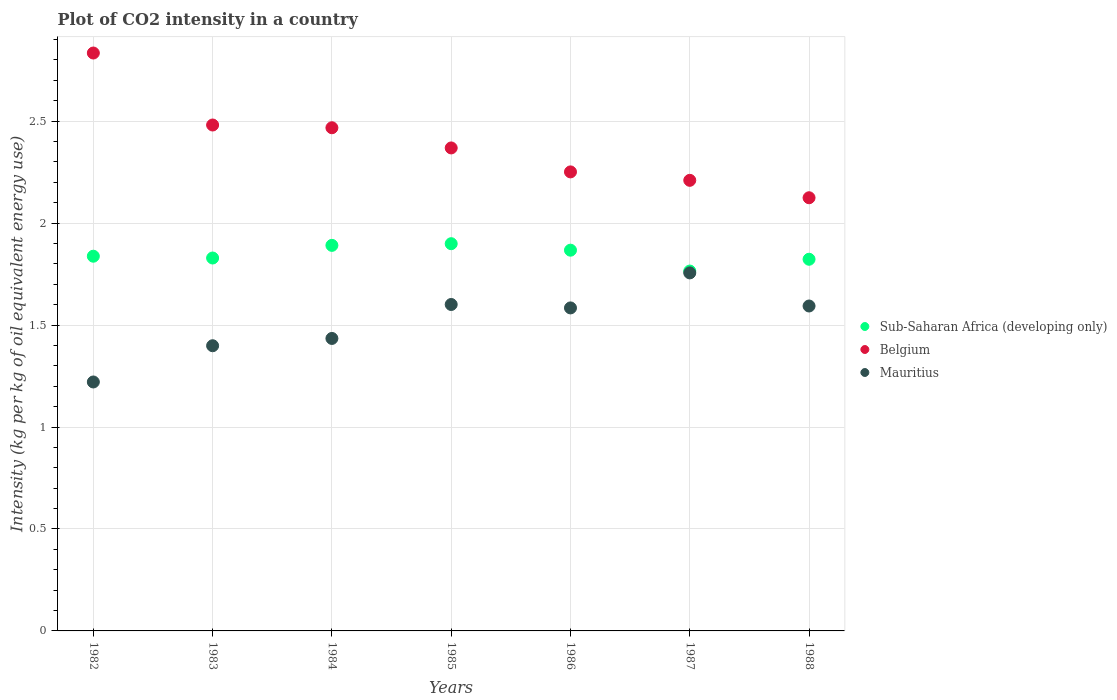How many different coloured dotlines are there?
Keep it short and to the point. 3. Is the number of dotlines equal to the number of legend labels?
Ensure brevity in your answer.  Yes. What is the CO2 intensity in in Sub-Saharan Africa (developing only) in 1984?
Offer a very short reply. 1.89. Across all years, what is the maximum CO2 intensity in in Belgium?
Provide a short and direct response. 2.83. Across all years, what is the minimum CO2 intensity in in Belgium?
Offer a very short reply. 2.12. What is the total CO2 intensity in in Belgium in the graph?
Provide a succinct answer. 16.74. What is the difference between the CO2 intensity in in Belgium in 1982 and that in 1984?
Your answer should be compact. 0.37. What is the difference between the CO2 intensity in in Mauritius in 1988 and the CO2 intensity in in Belgium in 1986?
Offer a very short reply. -0.66. What is the average CO2 intensity in in Sub-Saharan Africa (developing only) per year?
Keep it short and to the point. 1.84. In the year 1983, what is the difference between the CO2 intensity in in Belgium and CO2 intensity in in Sub-Saharan Africa (developing only)?
Your answer should be very brief. 0.65. In how many years, is the CO2 intensity in in Mauritius greater than 1 kg?
Provide a short and direct response. 7. What is the ratio of the CO2 intensity in in Belgium in 1982 to that in 1983?
Give a very brief answer. 1.14. Is the CO2 intensity in in Mauritius in 1984 less than that in 1987?
Offer a very short reply. Yes. What is the difference between the highest and the second highest CO2 intensity in in Belgium?
Offer a terse response. 0.35. What is the difference between the highest and the lowest CO2 intensity in in Belgium?
Make the answer very short. 0.71. In how many years, is the CO2 intensity in in Belgium greater than the average CO2 intensity in in Belgium taken over all years?
Offer a very short reply. 3. Is the sum of the CO2 intensity in in Mauritius in 1986 and 1988 greater than the maximum CO2 intensity in in Sub-Saharan Africa (developing only) across all years?
Offer a terse response. Yes. Is it the case that in every year, the sum of the CO2 intensity in in Belgium and CO2 intensity in in Sub-Saharan Africa (developing only)  is greater than the CO2 intensity in in Mauritius?
Your answer should be very brief. Yes. Is the CO2 intensity in in Mauritius strictly greater than the CO2 intensity in in Belgium over the years?
Your answer should be compact. No. What is the difference between two consecutive major ticks on the Y-axis?
Offer a very short reply. 0.5. Are the values on the major ticks of Y-axis written in scientific E-notation?
Offer a very short reply. No. How are the legend labels stacked?
Give a very brief answer. Vertical. What is the title of the graph?
Offer a very short reply. Plot of CO2 intensity in a country. What is the label or title of the X-axis?
Ensure brevity in your answer.  Years. What is the label or title of the Y-axis?
Offer a very short reply. Intensity (kg per kg of oil equivalent energy use). What is the Intensity (kg per kg of oil equivalent energy use) of Sub-Saharan Africa (developing only) in 1982?
Your answer should be compact. 1.84. What is the Intensity (kg per kg of oil equivalent energy use) in Belgium in 1982?
Make the answer very short. 2.83. What is the Intensity (kg per kg of oil equivalent energy use) in Mauritius in 1982?
Keep it short and to the point. 1.22. What is the Intensity (kg per kg of oil equivalent energy use) in Sub-Saharan Africa (developing only) in 1983?
Make the answer very short. 1.83. What is the Intensity (kg per kg of oil equivalent energy use) of Belgium in 1983?
Keep it short and to the point. 2.48. What is the Intensity (kg per kg of oil equivalent energy use) of Mauritius in 1983?
Provide a short and direct response. 1.4. What is the Intensity (kg per kg of oil equivalent energy use) in Sub-Saharan Africa (developing only) in 1984?
Make the answer very short. 1.89. What is the Intensity (kg per kg of oil equivalent energy use) of Belgium in 1984?
Offer a terse response. 2.47. What is the Intensity (kg per kg of oil equivalent energy use) in Mauritius in 1984?
Ensure brevity in your answer.  1.43. What is the Intensity (kg per kg of oil equivalent energy use) of Sub-Saharan Africa (developing only) in 1985?
Make the answer very short. 1.9. What is the Intensity (kg per kg of oil equivalent energy use) in Belgium in 1985?
Offer a very short reply. 2.37. What is the Intensity (kg per kg of oil equivalent energy use) in Mauritius in 1985?
Make the answer very short. 1.6. What is the Intensity (kg per kg of oil equivalent energy use) in Sub-Saharan Africa (developing only) in 1986?
Keep it short and to the point. 1.87. What is the Intensity (kg per kg of oil equivalent energy use) of Belgium in 1986?
Your response must be concise. 2.25. What is the Intensity (kg per kg of oil equivalent energy use) of Mauritius in 1986?
Your response must be concise. 1.58. What is the Intensity (kg per kg of oil equivalent energy use) in Sub-Saharan Africa (developing only) in 1987?
Keep it short and to the point. 1.76. What is the Intensity (kg per kg of oil equivalent energy use) in Belgium in 1987?
Make the answer very short. 2.21. What is the Intensity (kg per kg of oil equivalent energy use) of Mauritius in 1987?
Your answer should be very brief. 1.76. What is the Intensity (kg per kg of oil equivalent energy use) of Sub-Saharan Africa (developing only) in 1988?
Offer a terse response. 1.82. What is the Intensity (kg per kg of oil equivalent energy use) in Belgium in 1988?
Ensure brevity in your answer.  2.12. What is the Intensity (kg per kg of oil equivalent energy use) in Mauritius in 1988?
Make the answer very short. 1.59. Across all years, what is the maximum Intensity (kg per kg of oil equivalent energy use) in Sub-Saharan Africa (developing only)?
Offer a very short reply. 1.9. Across all years, what is the maximum Intensity (kg per kg of oil equivalent energy use) of Belgium?
Offer a terse response. 2.83. Across all years, what is the maximum Intensity (kg per kg of oil equivalent energy use) of Mauritius?
Your response must be concise. 1.76. Across all years, what is the minimum Intensity (kg per kg of oil equivalent energy use) in Sub-Saharan Africa (developing only)?
Your answer should be very brief. 1.76. Across all years, what is the minimum Intensity (kg per kg of oil equivalent energy use) of Belgium?
Make the answer very short. 2.12. Across all years, what is the minimum Intensity (kg per kg of oil equivalent energy use) of Mauritius?
Your answer should be compact. 1.22. What is the total Intensity (kg per kg of oil equivalent energy use) in Sub-Saharan Africa (developing only) in the graph?
Offer a very short reply. 12.91. What is the total Intensity (kg per kg of oil equivalent energy use) of Belgium in the graph?
Offer a very short reply. 16.74. What is the total Intensity (kg per kg of oil equivalent energy use) of Mauritius in the graph?
Offer a very short reply. 10.59. What is the difference between the Intensity (kg per kg of oil equivalent energy use) of Sub-Saharan Africa (developing only) in 1982 and that in 1983?
Provide a short and direct response. 0.01. What is the difference between the Intensity (kg per kg of oil equivalent energy use) in Belgium in 1982 and that in 1983?
Provide a short and direct response. 0.35. What is the difference between the Intensity (kg per kg of oil equivalent energy use) of Mauritius in 1982 and that in 1983?
Offer a very short reply. -0.18. What is the difference between the Intensity (kg per kg of oil equivalent energy use) in Sub-Saharan Africa (developing only) in 1982 and that in 1984?
Keep it short and to the point. -0.05. What is the difference between the Intensity (kg per kg of oil equivalent energy use) in Belgium in 1982 and that in 1984?
Your response must be concise. 0.37. What is the difference between the Intensity (kg per kg of oil equivalent energy use) of Mauritius in 1982 and that in 1984?
Give a very brief answer. -0.21. What is the difference between the Intensity (kg per kg of oil equivalent energy use) of Sub-Saharan Africa (developing only) in 1982 and that in 1985?
Make the answer very short. -0.06. What is the difference between the Intensity (kg per kg of oil equivalent energy use) in Belgium in 1982 and that in 1985?
Your response must be concise. 0.47. What is the difference between the Intensity (kg per kg of oil equivalent energy use) in Mauritius in 1982 and that in 1985?
Make the answer very short. -0.38. What is the difference between the Intensity (kg per kg of oil equivalent energy use) of Sub-Saharan Africa (developing only) in 1982 and that in 1986?
Your response must be concise. -0.03. What is the difference between the Intensity (kg per kg of oil equivalent energy use) of Belgium in 1982 and that in 1986?
Make the answer very short. 0.58. What is the difference between the Intensity (kg per kg of oil equivalent energy use) of Mauritius in 1982 and that in 1986?
Your answer should be very brief. -0.36. What is the difference between the Intensity (kg per kg of oil equivalent energy use) of Sub-Saharan Africa (developing only) in 1982 and that in 1987?
Make the answer very short. 0.07. What is the difference between the Intensity (kg per kg of oil equivalent energy use) of Belgium in 1982 and that in 1987?
Provide a short and direct response. 0.62. What is the difference between the Intensity (kg per kg of oil equivalent energy use) in Mauritius in 1982 and that in 1987?
Provide a short and direct response. -0.53. What is the difference between the Intensity (kg per kg of oil equivalent energy use) in Sub-Saharan Africa (developing only) in 1982 and that in 1988?
Provide a short and direct response. 0.01. What is the difference between the Intensity (kg per kg of oil equivalent energy use) in Belgium in 1982 and that in 1988?
Keep it short and to the point. 0.71. What is the difference between the Intensity (kg per kg of oil equivalent energy use) in Mauritius in 1982 and that in 1988?
Keep it short and to the point. -0.37. What is the difference between the Intensity (kg per kg of oil equivalent energy use) in Sub-Saharan Africa (developing only) in 1983 and that in 1984?
Offer a very short reply. -0.06. What is the difference between the Intensity (kg per kg of oil equivalent energy use) in Belgium in 1983 and that in 1984?
Make the answer very short. 0.01. What is the difference between the Intensity (kg per kg of oil equivalent energy use) in Mauritius in 1983 and that in 1984?
Keep it short and to the point. -0.04. What is the difference between the Intensity (kg per kg of oil equivalent energy use) of Sub-Saharan Africa (developing only) in 1983 and that in 1985?
Offer a very short reply. -0.07. What is the difference between the Intensity (kg per kg of oil equivalent energy use) in Belgium in 1983 and that in 1985?
Ensure brevity in your answer.  0.11. What is the difference between the Intensity (kg per kg of oil equivalent energy use) of Mauritius in 1983 and that in 1985?
Provide a succinct answer. -0.2. What is the difference between the Intensity (kg per kg of oil equivalent energy use) of Sub-Saharan Africa (developing only) in 1983 and that in 1986?
Give a very brief answer. -0.04. What is the difference between the Intensity (kg per kg of oil equivalent energy use) in Belgium in 1983 and that in 1986?
Your answer should be very brief. 0.23. What is the difference between the Intensity (kg per kg of oil equivalent energy use) in Mauritius in 1983 and that in 1986?
Offer a very short reply. -0.19. What is the difference between the Intensity (kg per kg of oil equivalent energy use) in Sub-Saharan Africa (developing only) in 1983 and that in 1987?
Provide a succinct answer. 0.06. What is the difference between the Intensity (kg per kg of oil equivalent energy use) in Belgium in 1983 and that in 1987?
Make the answer very short. 0.27. What is the difference between the Intensity (kg per kg of oil equivalent energy use) in Mauritius in 1983 and that in 1987?
Ensure brevity in your answer.  -0.36. What is the difference between the Intensity (kg per kg of oil equivalent energy use) of Sub-Saharan Africa (developing only) in 1983 and that in 1988?
Give a very brief answer. 0.01. What is the difference between the Intensity (kg per kg of oil equivalent energy use) of Belgium in 1983 and that in 1988?
Your response must be concise. 0.36. What is the difference between the Intensity (kg per kg of oil equivalent energy use) of Mauritius in 1983 and that in 1988?
Offer a terse response. -0.19. What is the difference between the Intensity (kg per kg of oil equivalent energy use) of Sub-Saharan Africa (developing only) in 1984 and that in 1985?
Make the answer very short. -0.01. What is the difference between the Intensity (kg per kg of oil equivalent energy use) in Belgium in 1984 and that in 1985?
Give a very brief answer. 0.1. What is the difference between the Intensity (kg per kg of oil equivalent energy use) of Mauritius in 1984 and that in 1985?
Make the answer very short. -0.17. What is the difference between the Intensity (kg per kg of oil equivalent energy use) in Sub-Saharan Africa (developing only) in 1984 and that in 1986?
Your answer should be compact. 0.02. What is the difference between the Intensity (kg per kg of oil equivalent energy use) in Belgium in 1984 and that in 1986?
Your response must be concise. 0.22. What is the difference between the Intensity (kg per kg of oil equivalent energy use) in Mauritius in 1984 and that in 1986?
Give a very brief answer. -0.15. What is the difference between the Intensity (kg per kg of oil equivalent energy use) of Sub-Saharan Africa (developing only) in 1984 and that in 1987?
Offer a terse response. 0.13. What is the difference between the Intensity (kg per kg of oil equivalent energy use) in Belgium in 1984 and that in 1987?
Offer a terse response. 0.26. What is the difference between the Intensity (kg per kg of oil equivalent energy use) of Mauritius in 1984 and that in 1987?
Keep it short and to the point. -0.32. What is the difference between the Intensity (kg per kg of oil equivalent energy use) in Sub-Saharan Africa (developing only) in 1984 and that in 1988?
Make the answer very short. 0.07. What is the difference between the Intensity (kg per kg of oil equivalent energy use) of Belgium in 1984 and that in 1988?
Provide a short and direct response. 0.34. What is the difference between the Intensity (kg per kg of oil equivalent energy use) in Mauritius in 1984 and that in 1988?
Provide a short and direct response. -0.16. What is the difference between the Intensity (kg per kg of oil equivalent energy use) of Sub-Saharan Africa (developing only) in 1985 and that in 1986?
Your answer should be compact. 0.03. What is the difference between the Intensity (kg per kg of oil equivalent energy use) of Belgium in 1985 and that in 1986?
Your response must be concise. 0.12. What is the difference between the Intensity (kg per kg of oil equivalent energy use) in Mauritius in 1985 and that in 1986?
Provide a succinct answer. 0.02. What is the difference between the Intensity (kg per kg of oil equivalent energy use) of Sub-Saharan Africa (developing only) in 1985 and that in 1987?
Offer a terse response. 0.13. What is the difference between the Intensity (kg per kg of oil equivalent energy use) in Belgium in 1985 and that in 1987?
Offer a very short reply. 0.16. What is the difference between the Intensity (kg per kg of oil equivalent energy use) in Mauritius in 1985 and that in 1987?
Keep it short and to the point. -0.15. What is the difference between the Intensity (kg per kg of oil equivalent energy use) in Sub-Saharan Africa (developing only) in 1985 and that in 1988?
Make the answer very short. 0.08. What is the difference between the Intensity (kg per kg of oil equivalent energy use) of Belgium in 1985 and that in 1988?
Provide a succinct answer. 0.24. What is the difference between the Intensity (kg per kg of oil equivalent energy use) in Mauritius in 1985 and that in 1988?
Ensure brevity in your answer.  0.01. What is the difference between the Intensity (kg per kg of oil equivalent energy use) in Sub-Saharan Africa (developing only) in 1986 and that in 1987?
Provide a short and direct response. 0.1. What is the difference between the Intensity (kg per kg of oil equivalent energy use) in Belgium in 1986 and that in 1987?
Keep it short and to the point. 0.04. What is the difference between the Intensity (kg per kg of oil equivalent energy use) of Mauritius in 1986 and that in 1987?
Make the answer very short. -0.17. What is the difference between the Intensity (kg per kg of oil equivalent energy use) of Sub-Saharan Africa (developing only) in 1986 and that in 1988?
Your answer should be very brief. 0.04. What is the difference between the Intensity (kg per kg of oil equivalent energy use) of Belgium in 1986 and that in 1988?
Your answer should be compact. 0.13. What is the difference between the Intensity (kg per kg of oil equivalent energy use) in Mauritius in 1986 and that in 1988?
Offer a terse response. -0.01. What is the difference between the Intensity (kg per kg of oil equivalent energy use) in Sub-Saharan Africa (developing only) in 1987 and that in 1988?
Keep it short and to the point. -0.06. What is the difference between the Intensity (kg per kg of oil equivalent energy use) in Belgium in 1987 and that in 1988?
Your response must be concise. 0.09. What is the difference between the Intensity (kg per kg of oil equivalent energy use) in Mauritius in 1987 and that in 1988?
Give a very brief answer. 0.16. What is the difference between the Intensity (kg per kg of oil equivalent energy use) of Sub-Saharan Africa (developing only) in 1982 and the Intensity (kg per kg of oil equivalent energy use) of Belgium in 1983?
Your response must be concise. -0.64. What is the difference between the Intensity (kg per kg of oil equivalent energy use) in Sub-Saharan Africa (developing only) in 1982 and the Intensity (kg per kg of oil equivalent energy use) in Mauritius in 1983?
Your answer should be very brief. 0.44. What is the difference between the Intensity (kg per kg of oil equivalent energy use) of Belgium in 1982 and the Intensity (kg per kg of oil equivalent energy use) of Mauritius in 1983?
Provide a succinct answer. 1.44. What is the difference between the Intensity (kg per kg of oil equivalent energy use) in Sub-Saharan Africa (developing only) in 1982 and the Intensity (kg per kg of oil equivalent energy use) in Belgium in 1984?
Make the answer very short. -0.63. What is the difference between the Intensity (kg per kg of oil equivalent energy use) of Sub-Saharan Africa (developing only) in 1982 and the Intensity (kg per kg of oil equivalent energy use) of Mauritius in 1984?
Provide a short and direct response. 0.4. What is the difference between the Intensity (kg per kg of oil equivalent energy use) in Belgium in 1982 and the Intensity (kg per kg of oil equivalent energy use) in Mauritius in 1984?
Provide a short and direct response. 1.4. What is the difference between the Intensity (kg per kg of oil equivalent energy use) in Sub-Saharan Africa (developing only) in 1982 and the Intensity (kg per kg of oil equivalent energy use) in Belgium in 1985?
Provide a short and direct response. -0.53. What is the difference between the Intensity (kg per kg of oil equivalent energy use) of Sub-Saharan Africa (developing only) in 1982 and the Intensity (kg per kg of oil equivalent energy use) of Mauritius in 1985?
Your response must be concise. 0.24. What is the difference between the Intensity (kg per kg of oil equivalent energy use) in Belgium in 1982 and the Intensity (kg per kg of oil equivalent energy use) in Mauritius in 1985?
Keep it short and to the point. 1.23. What is the difference between the Intensity (kg per kg of oil equivalent energy use) in Sub-Saharan Africa (developing only) in 1982 and the Intensity (kg per kg of oil equivalent energy use) in Belgium in 1986?
Provide a succinct answer. -0.41. What is the difference between the Intensity (kg per kg of oil equivalent energy use) of Sub-Saharan Africa (developing only) in 1982 and the Intensity (kg per kg of oil equivalent energy use) of Mauritius in 1986?
Your answer should be compact. 0.25. What is the difference between the Intensity (kg per kg of oil equivalent energy use) of Belgium in 1982 and the Intensity (kg per kg of oil equivalent energy use) of Mauritius in 1986?
Give a very brief answer. 1.25. What is the difference between the Intensity (kg per kg of oil equivalent energy use) of Sub-Saharan Africa (developing only) in 1982 and the Intensity (kg per kg of oil equivalent energy use) of Belgium in 1987?
Ensure brevity in your answer.  -0.37. What is the difference between the Intensity (kg per kg of oil equivalent energy use) of Sub-Saharan Africa (developing only) in 1982 and the Intensity (kg per kg of oil equivalent energy use) of Mauritius in 1987?
Your answer should be very brief. 0.08. What is the difference between the Intensity (kg per kg of oil equivalent energy use) of Belgium in 1982 and the Intensity (kg per kg of oil equivalent energy use) of Mauritius in 1987?
Offer a terse response. 1.08. What is the difference between the Intensity (kg per kg of oil equivalent energy use) of Sub-Saharan Africa (developing only) in 1982 and the Intensity (kg per kg of oil equivalent energy use) of Belgium in 1988?
Provide a succinct answer. -0.29. What is the difference between the Intensity (kg per kg of oil equivalent energy use) in Sub-Saharan Africa (developing only) in 1982 and the Intensity (kg per kg of oil equivalent energy use) in Mauritius in 1988?
Offer a terse response. 0.24. What is the difference between the Intensity (kg per kg of oil equivalent energy use) in Belgium in 1982 and the Intensity (kg per kg of oil equivalent energy use) in Mauritius in 1988?
Your answer should be compact. 1.24. What is the difference between the Intensity (kg per kg of oil equivalent energy use) in Sub-Saharan Africa (developing only) in 1983 and the Intensity (kg per kg of oil equivalent energy use) in Belgium in 1984?
Offer a terse response. -0.64. What is the difference between the Intensity (kg per kg of oil equivalent energy use) in Sub-Saharan Africa (developing only) in 1983 and the Intensity (kg per kg of oil equivalent energy use) in Mauritius in 1984?
Offer a terse response. 0.39. What is the difference between the Intensity (kg per kg of oil equivalent energy use) of Belgium in 1983 and the Intensity (kg per kg of oil equivalent energy use) of Mauritius in 1984?
Your response must be concise. 1.05. What is the difference between the Intensity (kg per kg of oil equivalent energy use) of Sub-Saharan Africa (developing only) in 1983 and the Intensity (kg per kg of oil equivalent energy use) of Belgium in 1985?
Your response must be concise. -0.54. What is the difference between the Intensity (kg per kg of oil equivalent energy use) in Sub-Saharan Africa (developing only) in 1983 and the Intensity (kg per kg of oil equivalent energy use) in Mauritius in 1985?
Provide a succinct answer. 0.23. What is the difference between the Intensity (kg per kg of oil equivalent energy use) of Belgium in 1983 and the Intensity (kg per kg of oil equivalent energy use) of Mauritius in 1985?
Your answer should be very brief. 0.88. What is the difference between the Intensity (kg per kg of oil equivalent energy use) of Sub-Saharan Africa (developing only) in 1983 and the Intensity (kg per kg of oil equivalent energy use) of Belgium in 1986?
Give a very brief answer. -0.42. What is the difference between the Intensity (kg per kg of oil equivalent energy use) of Sub-Saharan Africa (developing only) in 1983 and the Intensity (kg per kg of oil equivalent energy use) of Mauritius in 1986?
Provide a succinct answer. 0.24. What is the difference between the Intensity (kg per kg of oil equivalent energy use) in Belgium in 1983 and the Intensity (kg per kg of oil equivalent energy use) in Mauritius in 1986?
Your answer should be compact. 0.9. What is the difference between the Intensity (kg per kg of oil equivalent energy use) in Sub-Saharan Africa (developing only) in 1983 and the Intensity (kg per kg of oil equivalent energy use) in Belgium in 1987?
Keep it short and to the point. -0.38. What is the difference between the Intensity (kg per kg of oil equivalent energy use) in Sub-Saharan Africa (developing only) in 1983 and the Intensity (kg per kg of oil equivalent energy use) in Mauritius in 1987?
Ensure brevity in your answer.  0.07. What is the difference between the Intensity (kg per kg of oil equivalent energy use) in Belgium in 1983 and the Intensity (kg per kg of oil equivalent energy use) in Mauritius in 1987?
Offer a very short reply. 0.73. What is the difference between the Intensity (kg per kg of oil equivalent energy use) in Sub-Saharan Africa (developing only) in 1983 and the Intensity (kg per kg of oil equivalent energy use) in Belgium in 1988?
Offer a very short reply. -0.3. What is the difference between the Intensity (kg per kg of oil equivalent energy use) of Sub-Saharan Africa (developing only) in 1983 and the Intensity (kg per kg of oil equivalent energy use) of Mauritius in 1988?
Your answer should be very brief. 0.24. What is the difference between the Intensity (kg per kg of oil equivalent energy use) in Belgium in 1983 and the Intensity (kg per kg of oil equivalent energy use) in Mauritius in 1988?
Provide a succinct answer. 0.89. What is the difference between the Intensity (kg per kg of oil equivalent energy use) of Sub-Saharan Africa (developing only) in 1984 and the Intensity (kg per kg of oil equivalent energy use) of Belgium in 1985?
Offer a terse response. -0.48. What is the difference between the Intensity (kg per kg of oil equivalent energy use) of Sub-Saharan Africa (developing only) in 1984 and the Intensity (kg per kg of oil equivalent energy use) of Mauritius in 1985?
Provide a short and direct response. 0.29. What is the difference between the Intensity (kg per kg of oil equivalent energy use) of Belgium in 1984 and the Intensity (kg per kg of oil equivalent energy use) of Mauritius in 1985?
Provide a succinct answer. 0.87. What is the difference between the Intensity (kg per kg of oil equivalent energy use) of Sub-Saharan Africa (developing only) in 1984 and the Intensity (kg per kg of oil equivalent energy use) of Belgium in 1986?
Your response must be concise. -0.36. What is the difference between the Intensity (kg per kg of oil equivalent energy use) in Sub-Saharan Africa (developing only) in 1984 and the Intensity (kg per kg of oil equivalent energy use) in Mauritius in 1986?
Provide a short and direct response. 0.31. What is the difference between the Intensity (kg per kg of oil equivalent energy use) of Belgium in 1984 and the Intensity (kg per kg of oil equivalent energy use) of Mauritius in 1986?
Give a very brief answer. 0.88. What is the difference between the Intensity (kg per kg of oil equivalent energy use) of Sub-Saharan Africa (developing only) in 1984 and the Intensity (kg per kg of oil equivalent energy use) of Belgium in 1987?
Keep it short and to the point. -0.32. What is the difference between the Intensity (kg per kg of oil equivalent energy use) of Sub-Saharan Africa (developing only) in 1984 and the Intensity (kg per kg of oil equivalent energy use) of Mauritius in 1987?
Keep it short and to the point. 0.14. What is the difference between the Intensity (kg per kg of oil equivalent energy use) in Belgium in 1984 and the Intensity (kg per kg of oil equivalent energy use) in Mauritius in 1987?
Your answer should be very brief. 0.71. What is the difference between the Intensity (kg per kg of oil equivalent energy use) in Sub-Saharan Africa (developing only) in 1984 and the Intensity (kg per kg of oil equivalent energy use) in Belgium in 1988?
Your answer should be very brief. -0.23. What is the difference between the Intensity (kg per kg of oil equivalent energy use) in Sub-Saharan Africa (developing only) in 1984 and the Intensity (kg per kg of oil equivalent energy use) in Mauritius in 1988?
Keep it short and to the point. 0.3. What is the difference between the Intensity (kg per kg of oil equivalent energy use) of Belgium in 1984 and the Intensity (kg per kg of oil equivalent energy use) of Mauritius in 1988?
Your response must be concise. 0.87. What is the difference between the Intensity (kg per kg of oil equivalent energy use) in Sub-Saharan Africa (developing only) in 1985 and the Intensity (kg per kg of oil equivalent energy use) in Belgium in 1986?
Your answer should be compact. -0.35. What is the difference between the Intensity (kg per kg of oil equivalent energy use) of Sub-Saharan Africa (developing only) in 1985 and the Intensity (kg per kg of oil equivalent energy use) of Mauritius in 1986?
Your answer should be compact. 0.32. What is the difference between the Intensity (kg per kg of oil equivalent energy use) of Belgium in 1985 and the Intensity (kg per kg of oil equivalent energy use) of Mauritius in 1986?
Keep it short and to the point. 0.78. What is the difference between the Intensity (kg per kg of oil equivalent energy use) of Sub-Saharan Africa (developing only) in 1985 and the Intensity (kg per kg of oil equivalent energy use) of Belgium in 1987?
Provide a short and direct response. -0.31. What is the difference between the Intensity (kg per kg of oil equivalent energy use) in Sub-Saharan Africa (developing only) in 1985 and the Intensity (kg per kg of oil equivalent energy use) in Mauritius in 1987?
Provide a short and direct response. 0.14. What is the difference between the Intensity (kg per kg of oil equivalent energy use) of Belgium in 1985 and the Intensity (kg per kg of oil equivalent energy use) of Mauritius in 1987?
Ensure brevity in your answer.  0.61. What is the difference between the Intensity (kg per kg of oil equivalent energy use) in Sub-Saharan Africa (developing only) in 1985 and the Intensity (kg per kg of oil equivalent energy use) in Belgium in 1988?
Provide a succinct answer. -0.23. What is the difference between the Intensity (kg per kg of oil equivalent energy use) of Sub-Saharan Africa (developing only) in 1985 and the Intensity (kg per kg of oil equivalent energy use) of Mauritius in 1988?
Ensure brevity in your answer.  0.31. What is the difference between the Intensity (kg per kg of oil equivalent energy use) in Belgium in 1985 and the Intensity (kg per kg of oil equivalent energy use) in Mauritius in 1988?
Provide a succinct answer. 0.78. What is the difference between the Intensity (kg per kg of oil equivalent energy use) of Sub-Saharan Africa (developing only) in 1986 and the Intensity (kg per kg of oil equivalent energy use) of Belgium in 1987?
Your answer should be compact. -0.34. What is the difference between the Intensity (kg per kg of oil equivalent energy use) in Sub-Saharan Africa (developing only) in 1986 and the Intensity (kg per kg of oil equivalent energy use) in Mauritius in 1987?
Your response must be concise. 0.11. What is the difference between the Intensity (kg per kg of oil equivalent energy use) of Belgium in 1986 and the Intensity (kg per kg of oil equivalent energy use) of Mauritius in 1987?
Provide a short and direct response. 0.5. What is the difference between the Intensity (kg per kg of oil equivalent energy use) of Sub-Saharan Africa (developing only) in 1986 and the Intensity (kg per kg of oil equivalent energy use) of Belgium in 1988?
Your answer should be compact. -0.26. What is the difference between the Intensity (kg per kg of oil equivalent energy use) of Sub-Saharan Africa (developing only) in 1986 and the Intensity (kg per kg of oil equivalent energy use) of Mauritius in 1988?
Your response must be concise. 0.27. What is the difference between the Intensity (kg per kg of oil equivalent energy use) of Belgium in 1986 and the Intensity (kg per kg of oil equivalent energy use) of Mauritius in 1988?
Make the answer very short. 0.66. What is the difference between the Intensity (kg per kg of oil equivalent energy use) in Sub-Saharan Africa (developing only) in 1987 and the Intensity (kg per kg of oil equivalent energy use) in Belgium in 1988?
Keep it short and to the point. -0.36. What is the difference between the Intensity (kg per kg of oil equivalent energy use) in Sub-Saharan Africa (developing only) in 1987 and the Intensity (kg per kg of oil equivalent energy use) in Mauritius in 1988?
Provide a short and direct response. 0.17. What is the difference between the Intensity (kg per kg of oil equivalent energy use) of Belgium in 1987 and the Intensity (kg per kg of oil equivalent energy use) of Mauritius in 1988?
Your answer should be very brief. 0.62. What is the average Intensity (kg per kg of oil equivalent energy use) of Sub-Saharan Africa (developing only) per year?
Give a very brief answer. 1.84. What is the average Intensity (kg per kg of oil equivalent energy use) of Belgium per year?
Provide a short and direct response. 2.39. What is the average Intensity (kg per kg of oil equivalent energy use) in Mauritius per year?
Your answer should be very brief. 1.51. In the year 1982, what is the difference between the Intensity (kg per kg of oil equivalent energy use) of Sub-Saharan Africa (developing only) and Intensity (kg per kg of oil equivalent energy use) of Belgium?
Provide a short and direct response. -1. In the year 1982, what is the difference between the Intensity (kg per kg of oil equivalent energy use) in Sub-Saharan Africa (developing only) and Intensity (kg per kg of oil equivalent energy use) in Mauritius?
Keep it short and to the point. 0.62. In the year 1982, what is the difference between the Intensity (kg per kg of oil equivalent energy use) in Belgium and Intensity (kg per kg of oil equivalent energy use) in Mauritius?
Your response must be concise. 1.61. In the year 1983, what is the difference between the Intensity (kg per kg of oil equivalent energy use) in Sub-Saharan Africa (developing only) and Intensity (kg per kg of oil equivalent energy use) in Belgium?
Keep it short and to the point. -0.65. In the year 1983, what is the difference between the Intensity (kg per kg of oil equivalent energy use) in Sub-Saharan Africa (developing only) and Intensity (kg per kg of oil equivalent energy use) in Mauritius?
Keep it short and to the point. 0.43. In the year 1983, what is the difference between the Intensity (kg per kg of oil equivalent energy use) of Belgium and Intensity (kg per kg of oil equivalent energy use) of Mauritius?
Keep it short and to the point. 1.08. In the year 1984, what is the difference between the Intensity (kg per kg of oil equivalent energy use) of Sub-Saharan Africa (developing only) and Intensity (kg per kg of oil equivalent energy use) of Belgium?
Keep it short and to the point. -0.58. In the year 1984, what is the difference between the Intensity (kg per kg of oil equivalent energy use) of Sub-Saharan Africa (developing only) and Intensity (kg per kg of oil equivalent energy use) of Mauritius?
Your answer should be compact. 0.46. In the year 1985, what is the difference between the Intensity (kg per kg of oil equivalent energy use) in Sub-Saharan Africa (developing only) and Intensity (kg per kg of oil equivalent energy use) in Belgium?
Provide a succinct answer. -0.47. In the year 1985, what is the difference between the Intensity (kg per kg of oil equivalent energy use) of Sub-Saharan Africa (developing only) and Intensity (kg per kg of oil equivalent energy use) of Mauritius?
Offer a very short reply. 0.3. In the year 1985, what is the difference between the Intensity (kg per kg of oil equivalent energy use) in Belgium and Intensity (kg per kg of oil equivalent energy use) in Mauritius?
Your answer should be very brief. 0.77. In the year 1986, what is the difference between the Intensity (kg per kg of oil equivalent energy use) of Sub-Saharan Africa (developing only) and Intensity (kg per kg of oil equivalent energy use) of Belgium?
Provide a succinct answer. -0.38. In the year 1986, what is the difference between the Intensity (kg per kg of oil equivalent energy use) of Sub-Saharan Africa (developing only) and Intensity (kg per kg of oil equivalent energy use) of Mauritius?
Provide a short and direct response. 0.28. In the year 1986, what is the difference between the Intensity (kg per kg of oil equivalent energy use) of Belgium and Intensity (kg per kg of oil equivalent energy use) of Mauritius?
Your answer should be very brief. 0.67. In the year 1987, what is the difference between the Intensity (kg per kg of oil equivalent energy use) of Sub-Saharan Africa (developing only) and Intensity (kg per kg of oil equivalent energy use) of Belgium?
Keep it short and to the point. -0.44. In the year 1987, what is the difference between the Intensity (kg per kg of oil equivalent energy use) in Sub-Saharan Africa (developing only) and Intensity (kg per kg of oil equivalent energy use) in Mauritius?
Make the answer very short. 0.01. In the year 1987, what is the difference between the Intensity (kg per kg of oil equivalent energy use) in Belgium and Intensity (kg per kg of oil equivalent energy use) in Mauritius?
Make the answer very short. 0.45. In the year 1988, what is the difference between the Intensity (kg per kg of oil equivalent energy use) of Sub-Saharan Africa (developing only) and Intensity (kg per kg of oil equivalent energy use) of Belgium?
Keep it short and to the point. -0.3. In the year 1988, what is the difference between the Intensity (kg per kg of oil equivalent energy use) in Sub-Saharan Africa (developing only) and Intensity (kg per kg of oil equivalent energy use) in Mauritius?
Offer a terse response. 0.23. In the year 1988, what is the difference between the Intensity (kg per kg of oil equivalent energy use) of Belgium and Intensity (kg per kg of oil equivalent energy use) of Mauritius?
Provide a succinct answer. 0.53. What is the ratio of the Intensity (kg per kg of oil equivalent energy use) in Belgium in 1982 to that in 1983?
Keep it short and to the point. 1.14. What is the ratio of the Intensity (kg per kg of oil equivalent energy use) of Mauritius in 1982 to that in 1983?
Ensure brevity in your answer.  0.87. What is the ratio of the Intensity (kg per kg of oil equivalent energy use) in Sub-Saharan Africa (developing only) in 1982 to that in 1984?
Give a very brief answer. 0.97. What is the ratio of the Intensity (kg per kg of oil equivalent energy use) of Belgium in 1982 to that in 1984?
Keep it short and to the point. 1.15. What is the ratio of the Intensity (kg per kg of oil equivalent energy use) in Mauritius in 1982 to that in 1984?
Your answer should be compact. 0.85. What is the ratio of the Intensity (kg per kg of oil equivalent energy use) in Sub-Saharan Africa (developing only) in 1982 to that in 1985?
Make the answer very short. 0.97. What is the ratio of the Intensity (kg per kg of oil equivalent energy use) of Belgium in 1982 to that in 1985?
Make the answer very short. 1.2. What is the ratio of the Intensity (kg per kg of oil equivalent energy use) in Mauritius in 1982 to that in 1985?
Offer a terse response. 0.76. What is the ratio of the Intensity (kg per kg of oil equivalent energy use) in Sub-Saharan Africa (developing only) in 1982 to that in 1986?
Provide a succinct answer. 0.98. What is the ratio of the Intensity (kg per kg of oil equivalent energy use) in Belgium in 1982 to that in 1986?
Offer a terse response. 1.26. What is the ratio of the Intensity (kg per kg of oil equivalent energy use) in Mauritius in 1982 to that in 1986?
Give a very brief answer. 0.77. What is the ratio of the Intensity (kg per kg of oil equivalent energy use) in Sub-Saharan Africa (developing only) in 1982 to that in 1987?
Offer a terse response. 1.04. What is the ratio of the Intensity (kg per kg of oil equivalent energy use) of Belgium in 1982 to that in 1987?
Give a very brief answer. 1.28. What is the ratio of the Intensity (kg per kg of oil equivalent energy use) of Mauritius in 1982 to that in 1987?
Provide a succinct answer. 0.7. What is the ratio of the Intensity (kg per kg of oil equivalent energy use) in Sub-Saharan Africa (developing only) in 1982 to that in 1988?
Provide a short and direct response. 1.01. What is the ratio of the Intensity (kg per kg of oil equivalent energy use) of Belgium in 1982 to that in 1988?
Keep it short and to the point. 1.33. What is the ratio of the Intensity (kg per kg of oil equivalent energy use) in Mauritius in 1982 to that in 1988?
Keep it short and to the point. 0.77. What is the ratio of the Intensity (kg per kg of oil equivalent energy use) in Sub-Saharan Africa (developing only) in 1983 to that in 1984?
Ensure brevity in your answer.  0.97. What is the ratio of the Intensity (kg per kg of oil equivalent energy use) of Belgium in 1983 to that in 1984?
Provide a succinct answer. 1.01. What is the ratio of the Intensity (kg per kg of oil equivalent energy use) in Mauritius in 1983 to that in 1984?
Your answer should be very brief. 0.98. What is the ratio of the Intensity (kg per kg of oil equivalent energy use) in Belgium in 1983 to that in 1985?
Your answer should be very brief. 1.05. What is the ratio of the Intensity (kg per kg of oil equivalent energy use) in Mauritius in 1983 to that in 1985?
Provide a short and direct response. 0.87. What is the ratio of the Intensity (kg per kg of oil equivalent energy use) in Sub-Saharan Africa (developing only) in 1983 to that in 1986?
Provide a short and direct response. 0.98. What is the ratio of the Intensity (kg per kg of oil equivalent energy use) in Belgium in 1983 to that in 1986?
Ensure brevity in your answer.  1.1. What is the ratio of the Intensity (kg per kg of oil equivalent energy use) in Mauritius in 1983 to that in 1986?
Give a very brief answer. 0.88. What is the ratio of the Intensity (kg per kg of oil equivalent energy use) of Sub-Saharan Africa (developing only) in 1983 to that in 1987?
Your response must be concise. 1.04. What is the ratio of the Intensity (kg per kg of oil equivalent energy use) in Belgium in 1983 to that in 1987?
Your answer should be very brief. 1.12. What is the ratio of the Intensity (kg per kg of oil equivalent energy use) of Mauritius in 1983 to that in 1987?
Offer a very short reply. 0.8. What is the ratio of the Intensity (kg per kg of oil equivalent energy use) of Belgium in 1983 to that in 1988?
Make the answer very short. 1.17. What is the ratio of the Intensity (kg per kg of oil equivalent energy use) of Mauritius in 1983 to that in 1988?
Offer a very short reply. 0.88. What is the ratio of the Intensity (kg per kg of oil equivalent energy use) in Sub-Saharan Africa (developing only) in 1984 to that in 1985?
Keep it short and to the point. 1. What is the ratio of the Intensity (kg per kg of oil equivalent energy use) in Belgium in 1984 to that in 1985?
Ensure brevity in your answer.  1.04. What is the ratio of the Intensity (kg per kg of oil equivalent energy use) of Mauritius in 1984 to that in 1985?
Provide a short and direct response. 0.9. What is the ratio of the Intensity (kg per kg of oil equivalent energy use) in Sub-Saharan Africa (developing only) in 1984 to that in 1986?
Make the answer very short. 1.01. What is the ratio of the Intensity (kg per kg of oil equivalent energy use) of Belgium in 1984 to that in 1986?
Ensure brevity in your answer.  1.1. What is the ratio of the Intensity (kg per kg of oil equivalent energy use) in Mauritius in 1984 to that in 1986?
Your answer should be very brief. 0.91. What is the ratio of the Intensity (kg per kg of oil equivalent energy use) in Sub-Saharan Africa (developing only) in 1984 to that in 1987?
Make the answer very short. 1.07. What is the ratio of the Intensity (kg per kg of oil equivalent energy use) in Belgium in 1984 to that in 1987?
Your answer should be very brief. 1.12. What is the ratio of the Intensity (kg per kg of oil equivalent energy use) in Mauritius in 1984 to that in 1987?
Provide a succinct answer. 0.82. What is the ratio of the Intensity (kg per kg of oil equivalent energy use) in Sub-Saharan Africa (developing only) in 1984 to that in 1988?
Provide a short and direct response. 1.04. What is the ratio of the Intensity (kg per kg of oil equivalent energy use) in Belgium in 1984 to that in 1988?
Provide a short and direct response. 1.16. What is the ratio of the Intensity (kg per kg of oil equivalent energy use) in Mauritius in 1984 to that in 1988?
Provide a succinct answer. 0.9. What is the ratio of the Intensity (kg per kg of oil equivalent energy use) of Belgium in 1985 to that in 1986?
Give a very brief answer. 1.05. What is the ratio of the Intensity (kg per kg of oil equivalent energy use) in Mauritius in 1985 to that in 1986?
Offer a very short reply. 1.01. What is the ratio of the Intensity (kg per kg of oil equivalent energy use) in Sub-Saharan Africa (developing only) in 1985 to that in 1987?
Give a very brief answer. 1.08. What is the ratio of the Intensity (kg per kg of oil equivalent energy use) of Belgium in 1985 to that in 1987?
Your answer should be very brief. 1.07. What is the ratio of the Intensity (kg per kg of oil equivalent energy use) of Mauritius in 1985 to that in 1987?
Provide a succinct answer. 0.91. What is the ratio of the Intensity (kg per kg of oil equivalent energy use) in Sub-Saharan Africa (developing only) in 1985 to that in 1988?
Give a very brief answer. 1.04. What is the ratio of the Intensity (kg per kg of oil equivalent energy use) of Belgium in 1985 to that in 1988?
Your answer should be very brief. 1.11. What is the ratio of the Intensity (kg per kg of oil equivalent energy use) of Mauritius in 1985 to that in 1988?
Your answer should be very brief. 1. What is the ratio of the Intensity (kg per kg of oil equivalent energy use) of Sub-Saharan Africa (developing only) in 1986 to that in 1987?
Provide a short and direct response. 1.06. What is the ratio of the Intensity (kg per kg of oil equivalent energy use) of Belgium in 1986 to that in 1987?
Offer a very short reply. 1.02. What is the ratio of the Intensity (kg per kg of oil equivalent energy use) in Mauritius in 1986 to that in 1987?
Make the answer very short. 0.9. What is the ratio of the Intensity (kg per kg of oil equivalent energy use) of Sub-Saharan Africa (developing only) in 1986 to that in 1988?
Offer a terse response. 1.02. What is the ratio of the Intensity (kg per kg of oil equivalent energy use) of Belgium in 1986 to that in 1988?
Your response must be concise. 1.06. What is the ratio of the Intensity (kg per kg of oil equivalent energy use) in Mauritius in 1986 to that in 1988?
Offer a very short reply. 0.99. What is the ratio of the Intensity (kg per kg of oil equivalent energy use) in Sub-Saharan Africa (developing only) in 1987 to that in 1988?
Your answer should be very brief. 0.97. What is the ratio of the Intensity (kg per kg of oil equivalent energy use) in Belgium in 1987 to that in 1988?
Your answer should be very brief. 1.04. What is the ratio of the Intensity (kg per kg of oil equivalent energy use) of Mauritius in 1987 to that in 1988?
Make the answer very short. 1.1. What is the difference between the highest and the second highest Intensity (kg per kg of oil equivalent energy use) of Sub-Saharan Africa (developing only)?
Offer a very short reply. 0.01. What is the difference between the highest and the second highest Intensity (kg per kg of oil equivalent energy use) of Belgium?
Provide a short and direct response. 0.35. What is the difference between the highest and the second highest Intensity (kg per kg of oil equivalent energy use) in Mauritius?
Offer a very short reply. 0.15. What is the difference between the highest and the lowest Intensity (kg per kg of oil equivalent energy use) in Sub-Saharan Africa (developing only)?
Provide a succinct answer. 0.13. What is the difference between the highest and the lowest Intensity (kg per kg of oil equivalent energy use) of Belgium?
Your answer should be very brief. 0.71. What is the difference between the highest and the lowest Intensity (kg per kg of oil equivalent energy use) in Mauritius?
Ensure brevity in your answer.  0.53. 